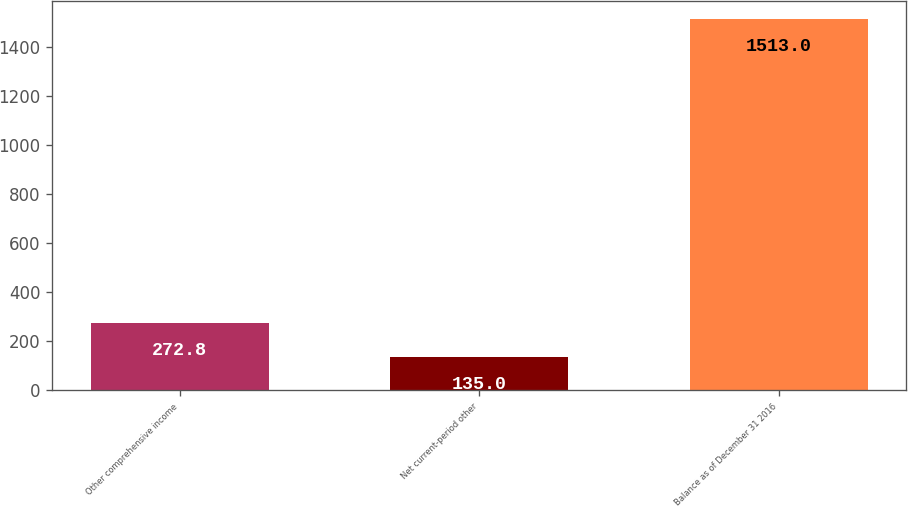Convert chart. <chart><loc_0><loc_0><loc_500><loc_500><bar_chart><fcel>Other comprehensive income<fcel>Net current-period other<fcel>Balance as of December 31 2016<nl><fcel>272.8<fcel>135<fcel>1513<nl></chart> 